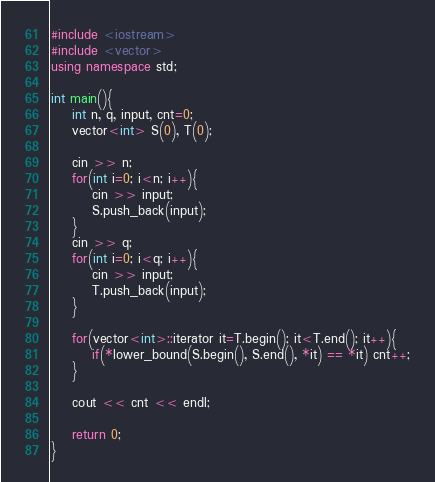<code> <loc_0><loc_0><loc_500><loc_500><_C++_>#include <iostream>
#include <vector>
using namespace std;

int main(){
    int n, q, input, cnt=0;
    vector<int> S(0), T(0);

    cin >> n;
    for(int i=0; i<n; i++){
        cin >> input;
        S.push_back(input);
    }
    cin >> q;
    for(int i=0; i<q; i++){
        cin >> input;
        T.push_back(input);
    }

    for(vector<int>::iterator it=T.begin(); it<T.end(); it++){
        if(*lower_bound(S.begin(), S.end(), *it) == *it) cnt++;
    }

    cout << cnt << endl;

    return 0;
}
</code> 